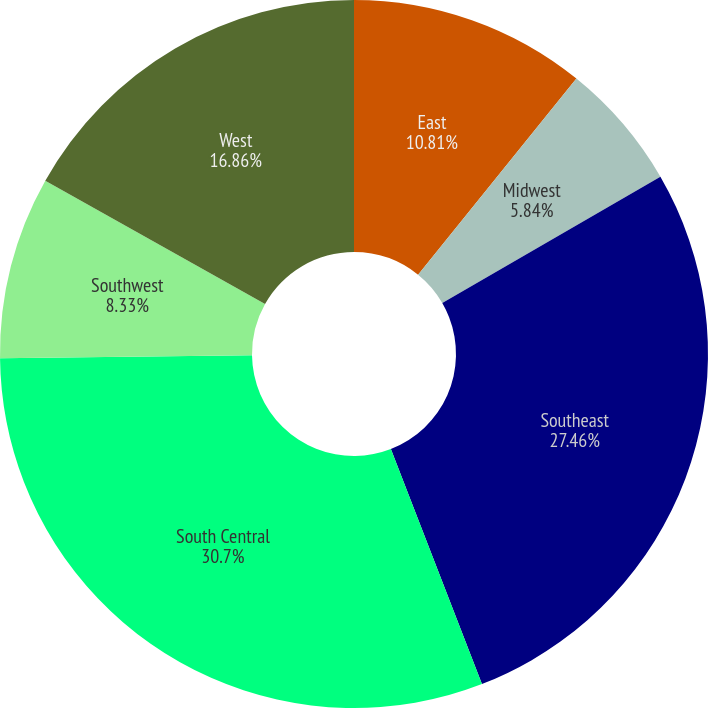Convert chart. <chart><loc_0><loc_0><loc_500><loc_500><pie_chart><fcel>East<fcel>Midwest<fcel>Southeast<fcel>South Central<fcel>Southwest<fcel>West<nl><fcel>10.81%<fcel>5.84%<fcel>27.46%<fcel>30.69%<fcel>8.33%<fcel>16.86%<nl></chart> 